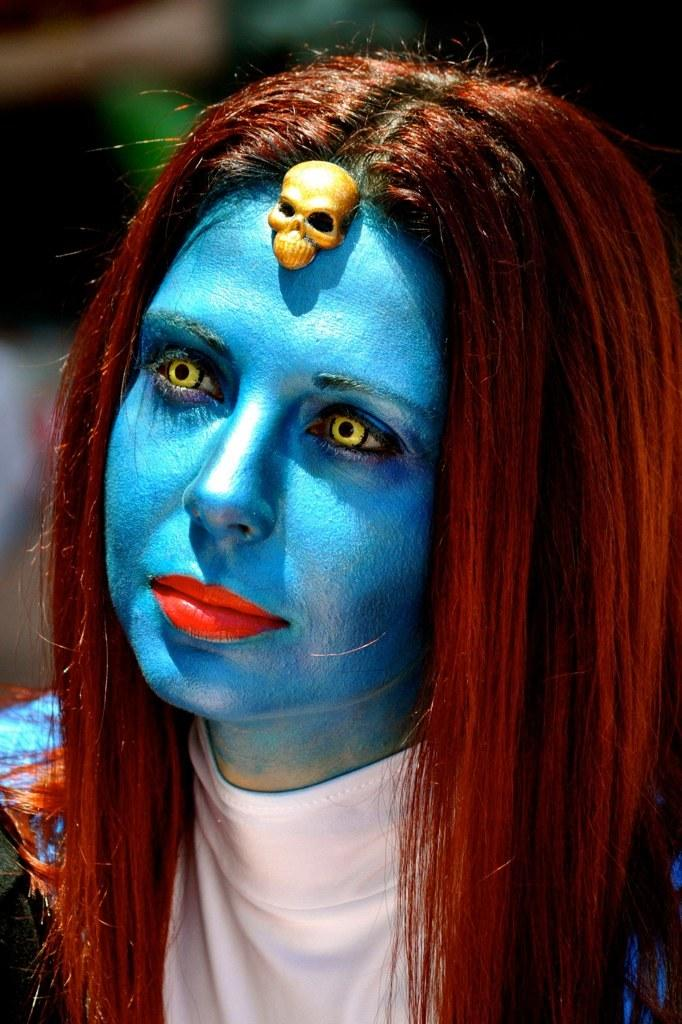Who is the main subject in the image? There is a woman in the image. What is a noticeable feature on the woman's face? The woman has blue paint on her face. What accessory is on the woman's forehead? There is a skull doll on the woman's forehead. How would you describe the background of the image? The background of the image is blurred. What type of chair is the woman sitting on in the image? There is no chair present in the image; the woman is standing. What list is the woman holding in the image? There is no list present in the image. 